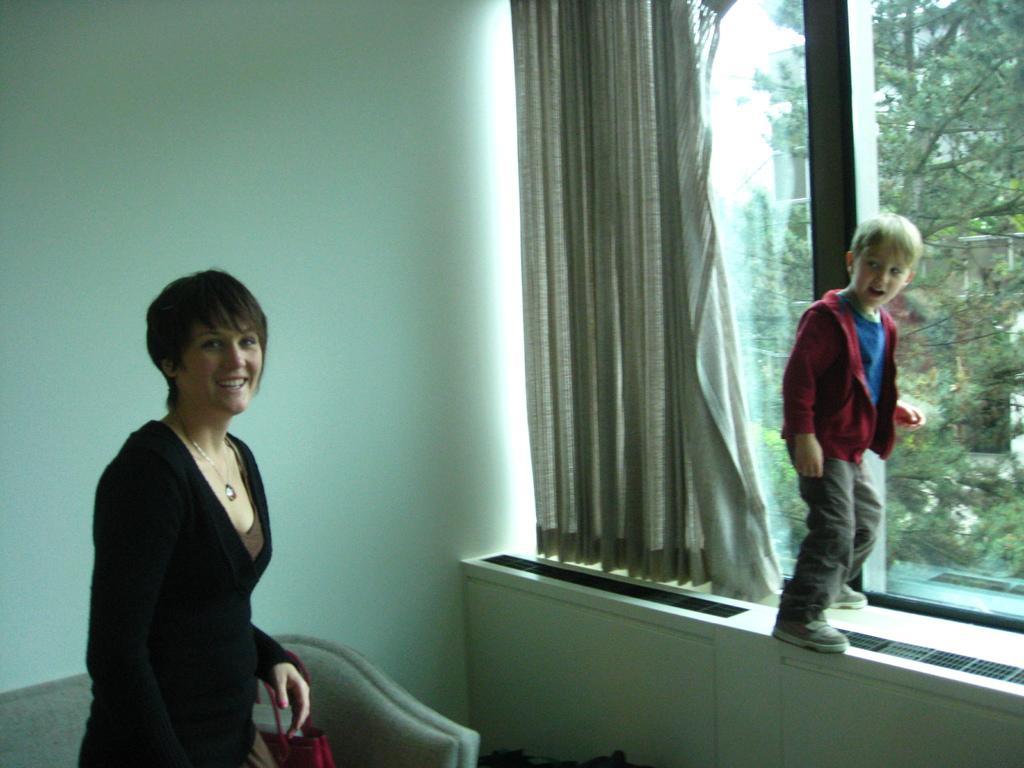Describe this image in one or two sentences. In this image we can see a woman smiling and holding a bag. We can also see a boy standing on the counter. There is also a glass window and a curtain and through the glass window we can see the trees. The image also consists of a sofa and a plain wall. 